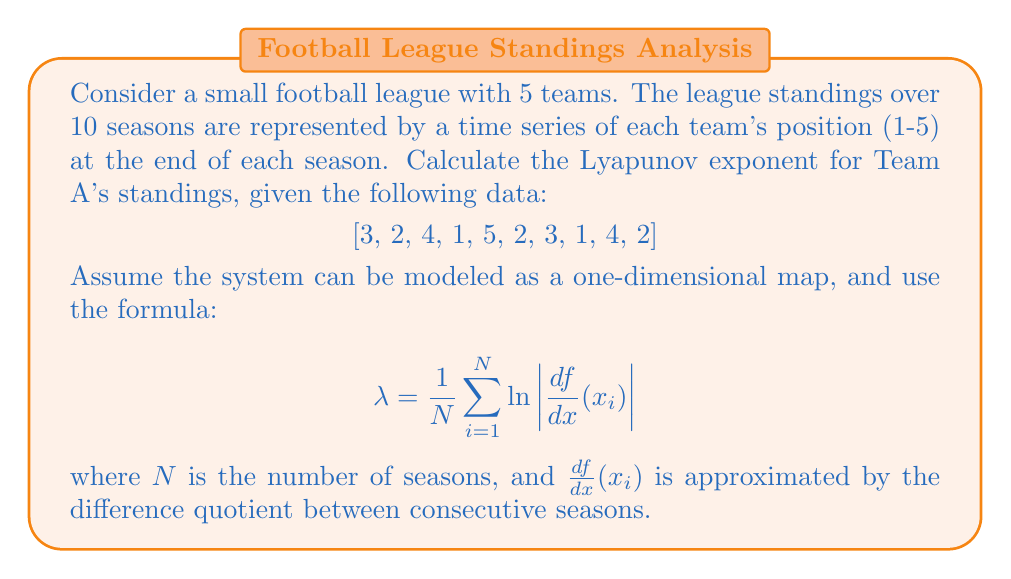Provide a solution to this math problem. To calculate the Lyapunov exponent for Team A's standings, we'll follow these steps:

1. Calculate the difference quotient for each pair of consecutive seasons:
   $\frac{df}{dx}(x_i) \approx \frac{x_{i+1} - x_i}{1}$ for $i = 1$ to $N-1$

2. Take the absolute value of each difference quotient.

3. Calculate the natural logarithm of each absolute value.

4. Sum up all the logarithms.

5. Divide the sum by $N$ (number of seasons) to get the Lyapunov exponent.

Let's perform these calculations:

1. Difference quotients:
   $(2-3) = -1$, $(4-2) = 2$, $(1-4) = -3$, $(5-1) = 4$, $(2-5) = -3$, $(3-2) = 1$, $(1-3) = -2$, $(4-1) = 3$, $(2-4) = -2$

2. Absolute values:
   $1$, $2$, $3$, $4$, $3$, $1$, $2$, $3$, $2$

3. Natural logarithms:
   $\ln(1) = 0$, $\ln(2) \approx 0.6931$, $\ln(3) \approx 1.0986$, $\ln(4) \approx 1.3863$

4. Sum of logarithms:
   $0 + 0.6931 + 1.0986 + 1.3863 + 1.0986 + 0 + 0.6931 + 1.0986 + 0.6931 \approx 6.7614$

5. Lyapunov exponent:
   $\lambda = \frac{6.7614}{10} \approx 0.6761$

The positive Lyapunov exponent indicates that the system is chaotic, suggesting unpredictability in Team A's league standings over time.
Answer: $\lambda \approx 0.6761$ 